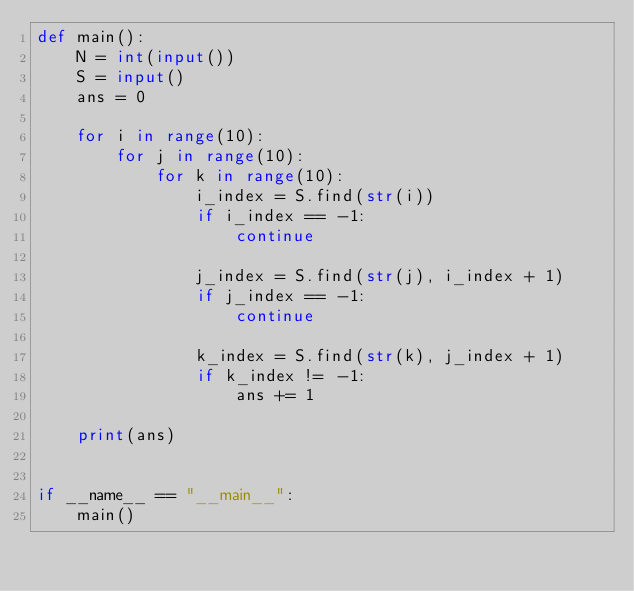Convert code to text. <code><loc_0><loc_0><loc_500><loc_500><_Python_>def main():
    N = int(input())
    S = input()
    ans = 0

    for i in range(10):
        for j in range(10):
            for k in range(10):
                i_index = S.find(str(i))
                if i_index == -1:
                    continue

                j_index = S.find(str(j), i_index + 1)
                if j_index == -1:
                    continue

                k_index = S.find(str(k), j_index + 1)
                if k_index != -1:
                    ans += 1

    print(ans)


if __name__ == "__main__":
    main()
</code> 